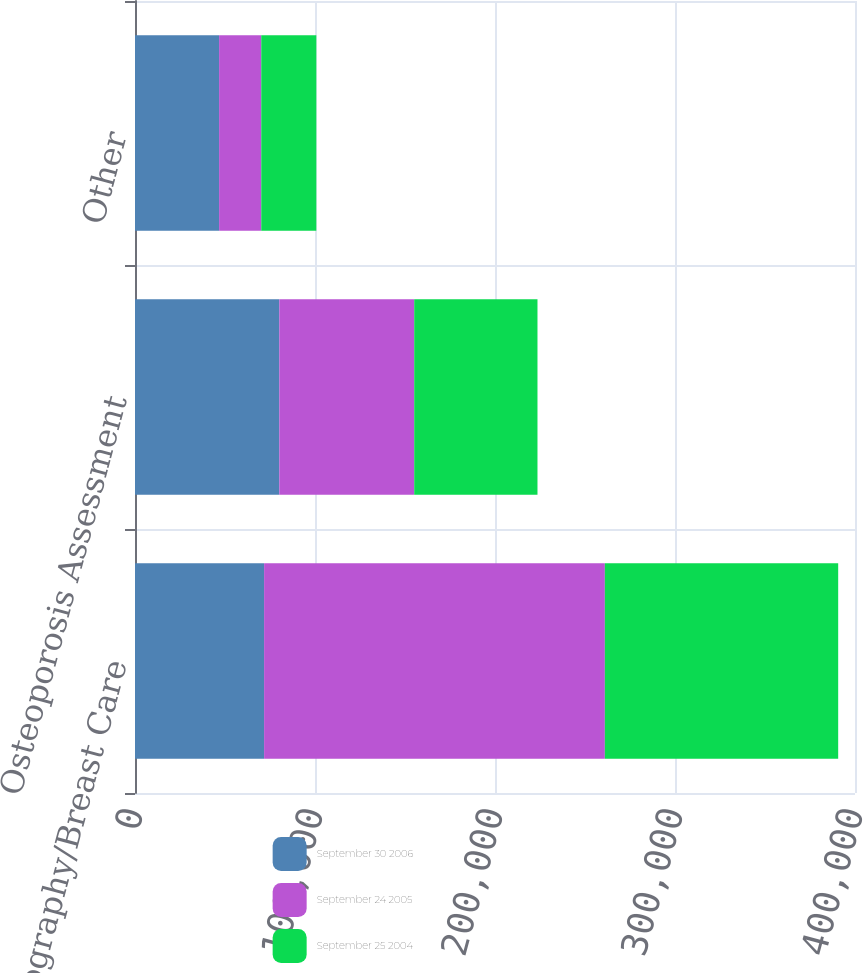Convert chart. <chart><loc_0><loc_0><loc_500><loc_500><stacked_bar_chart><ecel><fcel>Mammography/Breast Care<fcel>Osteoporosis Assessment<fcel>Other<nl><fcel>September 30 2006<fcel>71720<fcel>80162<fcel>46723<nl><fcel>September 24 2005<fcel>189313<fcel>74957<fcel>23414<nl><fcel>September 25 2004<fcel>129626<fcel>68483<fcel>30596<nl></chart> 